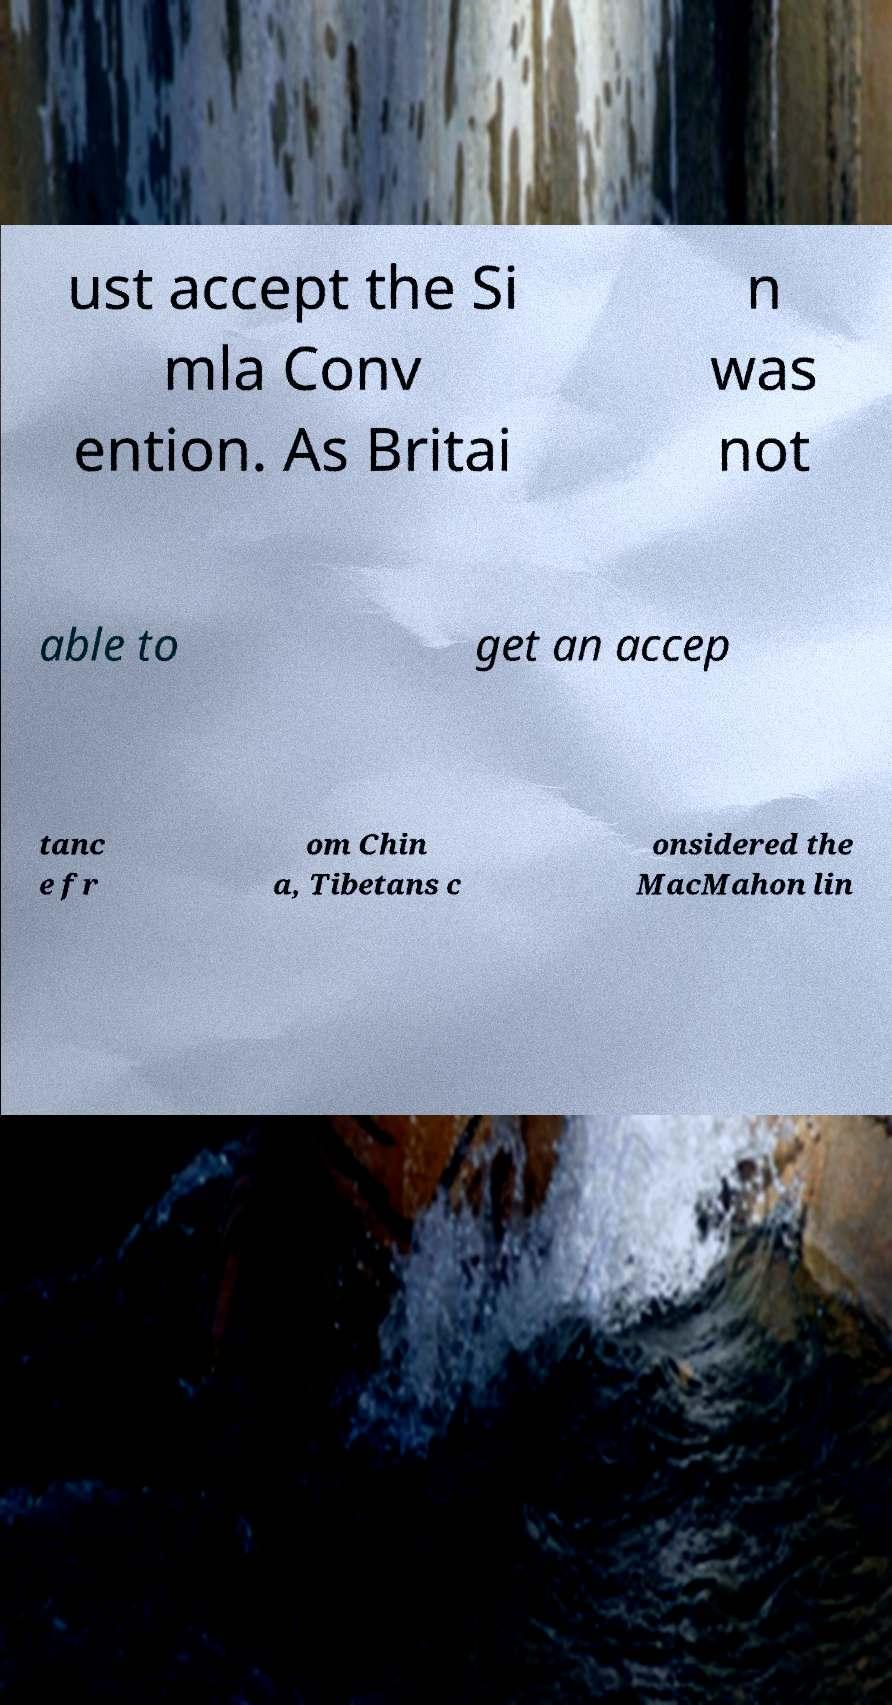Could you extract and type out the text from this image? ust accept the Si mla Conv ention. As Britai n was not able to get an accep tanc e fr om Chin a, Tibetans c onsidered the MacMahon lin 